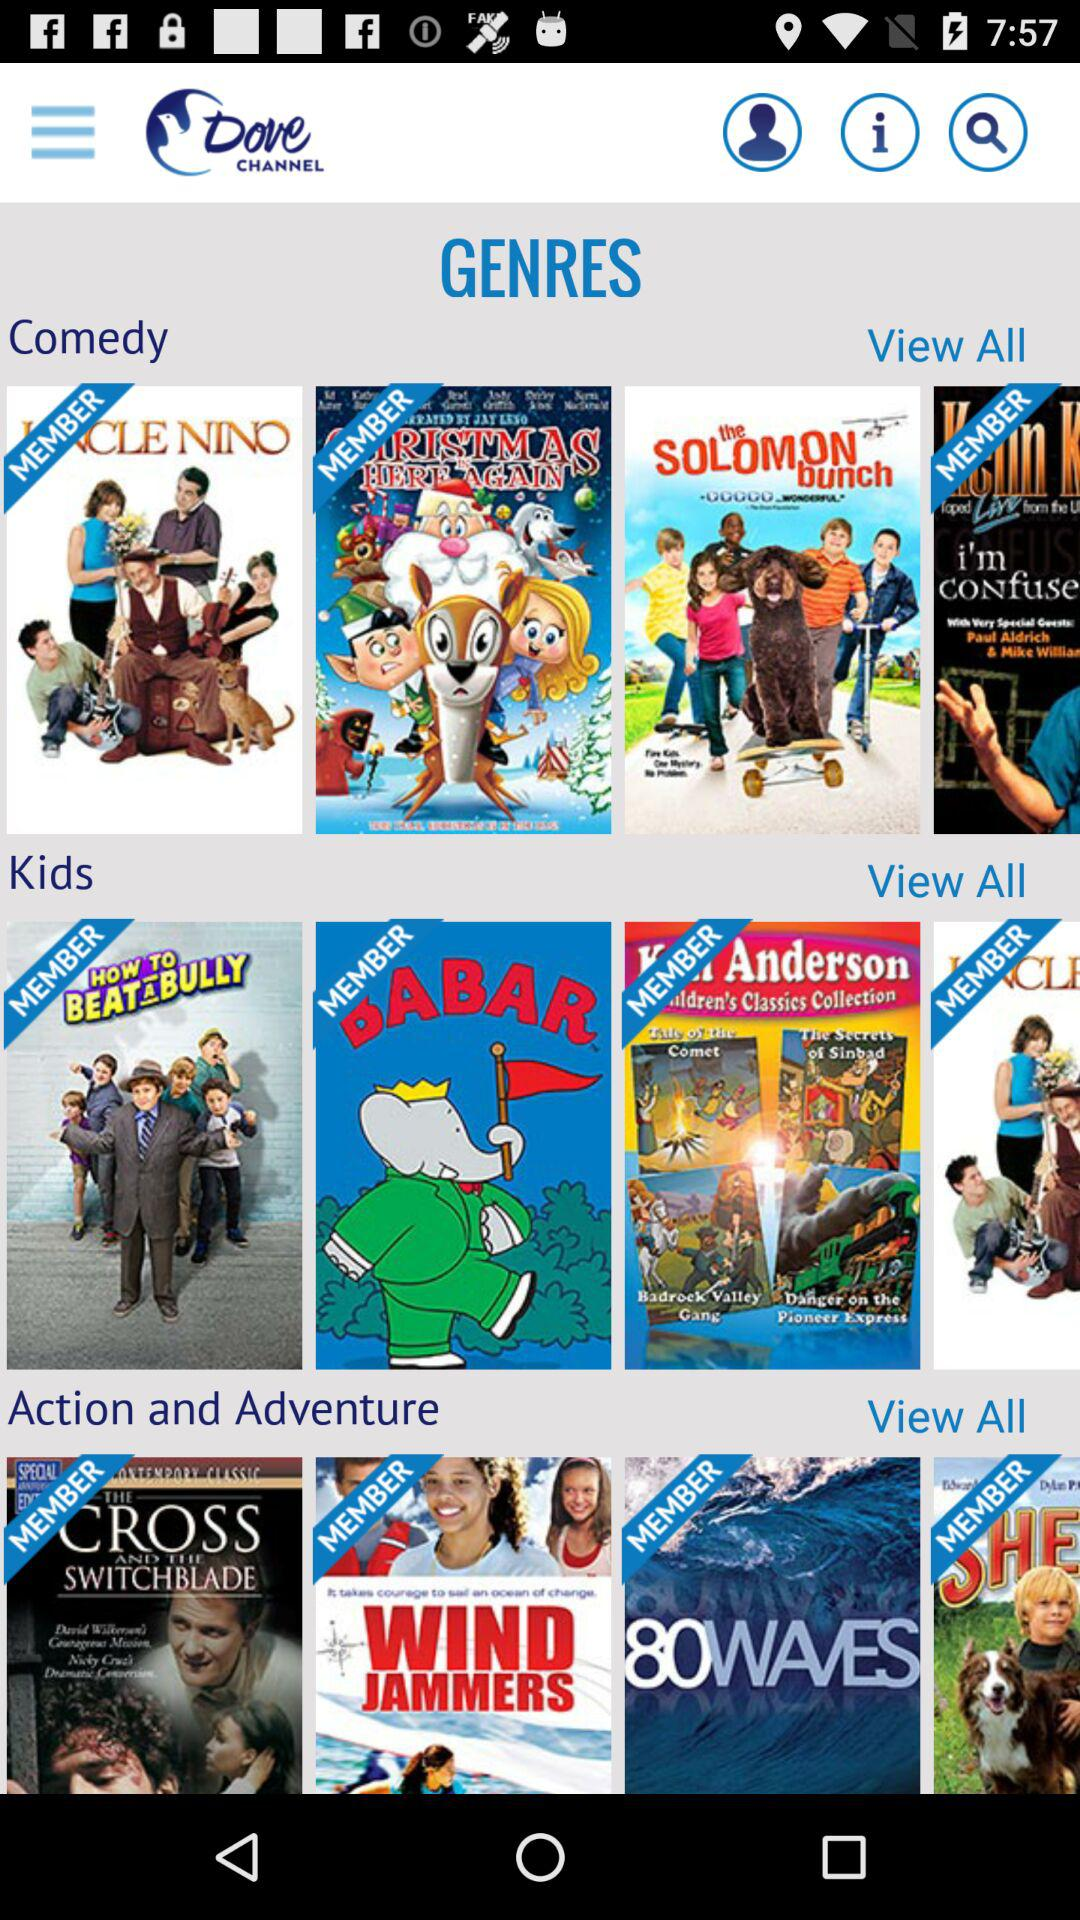What is the user's name?
When the provided information is insufficient, respond with <no answer>. <no answer> 